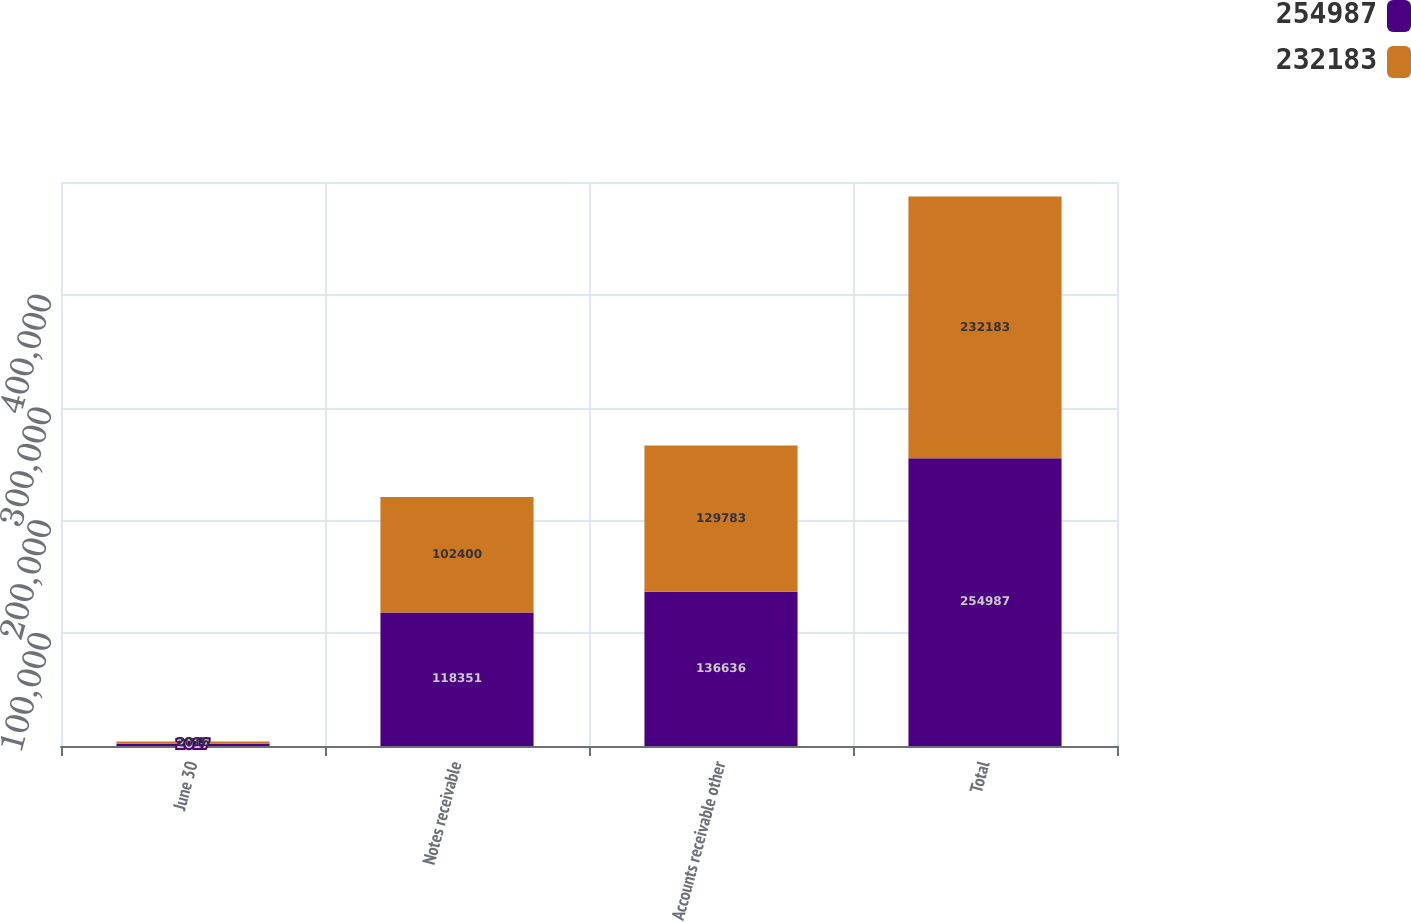<chart> <loc_0><loc_0><loc_500><loc_500><stacked_bar_chart><ecel><fcel>June 30<fcel>Notes receivable<fcel>Accounts receivable other<fcel>Total<nl><fcel>254987<fcel>2017<fcel>118351<fcel>136636<fcel>254987<nl><fcel>232183<fcel>2016<fcel>102400<fcel>129783<fcel>232183<nl></chart> 